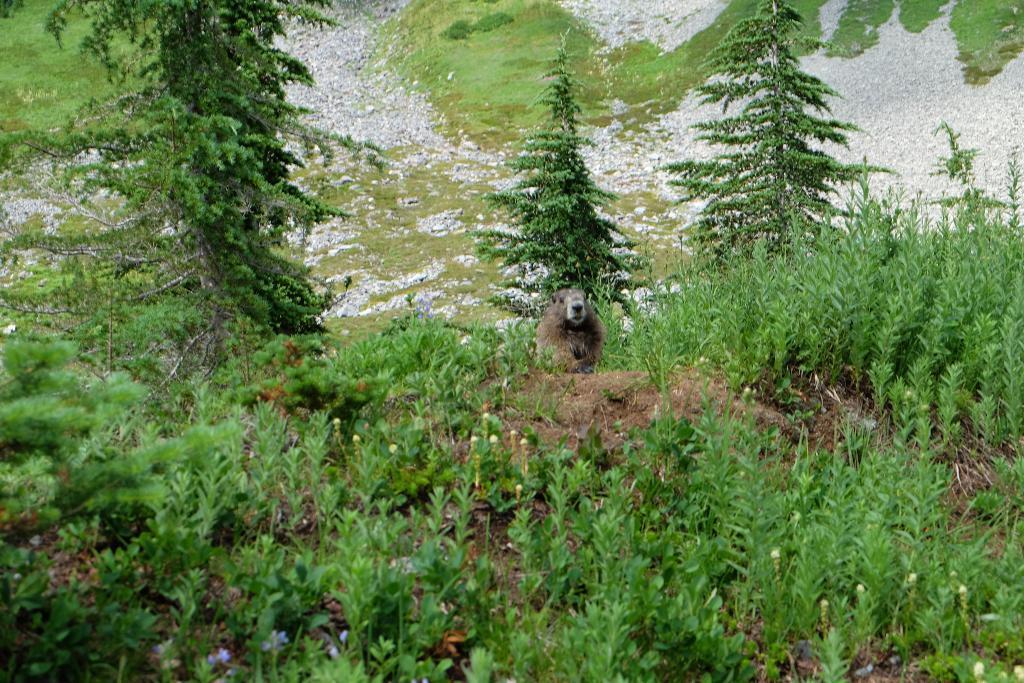How would you summarize this image in a sentence or two? This is an outside view. Hear I can see few plants, trees and stones on the ground. In the middle of the image I can see an animal on the ground. 